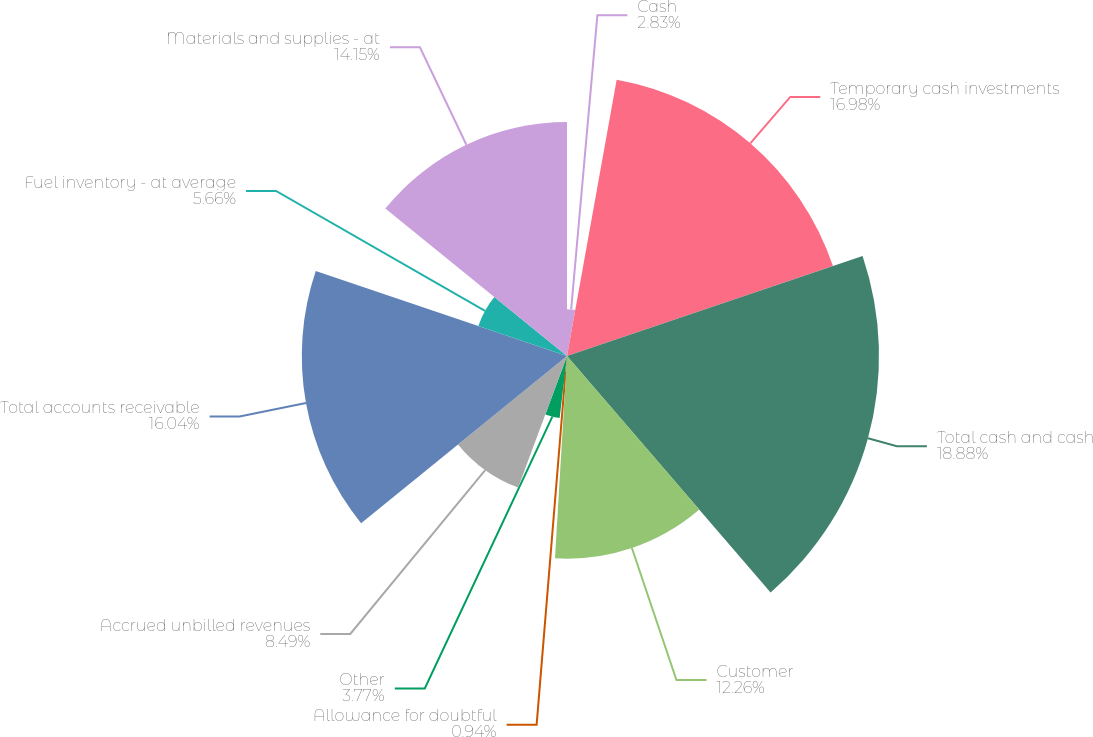<chart> <loc_0><loc_0><loc_500><loc_500><pie_chart><fcel>Cash<fcel>Temporary cash investments<fcel>Total cash and cash<fcel>Customer<fcel>Allowance for doubtful<fcel>Other<fcel>Accrued unbilled revenues<fcel>Total accounts receivable<fcel>Fuel inventory - at average<fcel>Materials and supplies - at<nl><fcel>2.83%<fcel>16.98%<fcel>18.87%<fcel>12.26%<fcel>0.94%<fcel>3.77%<fcel>8.49%<fcel>16.04%<fcel>5.66%<fcel>14.15%<nl></chart> 